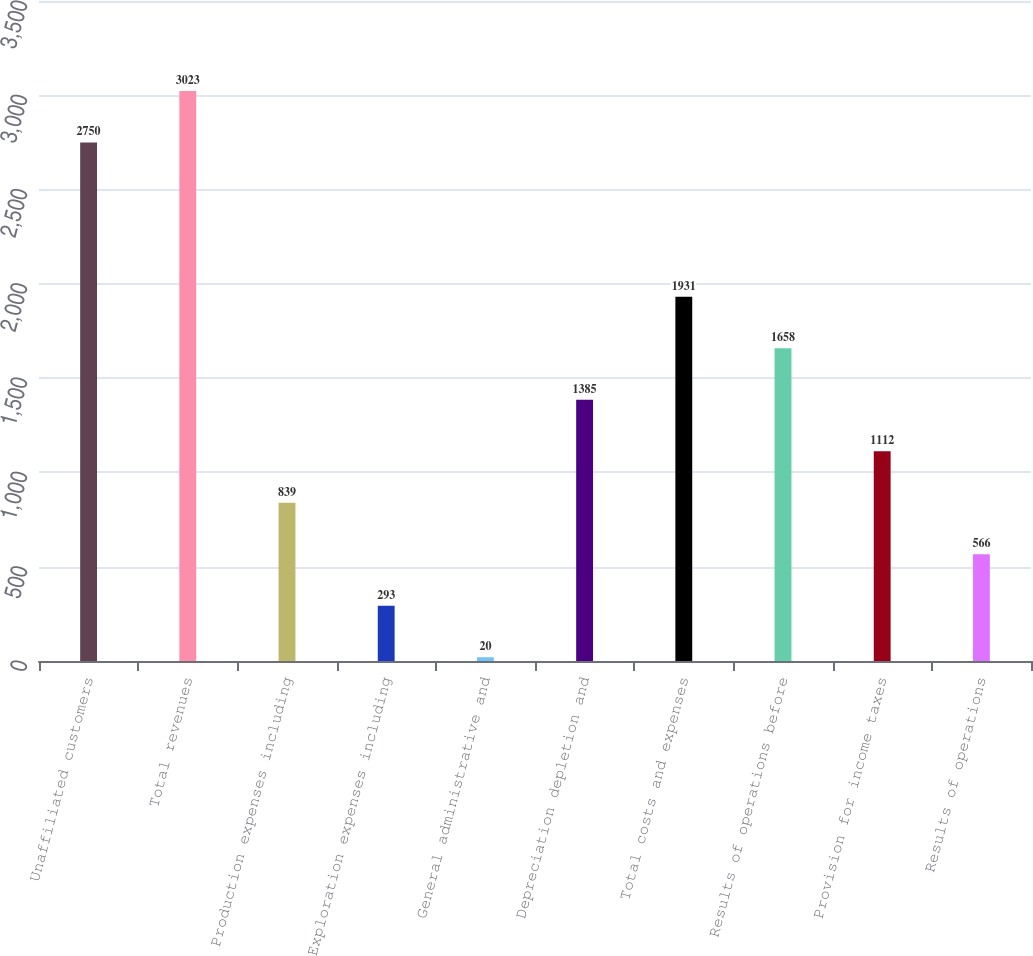Convert chart to OTSL. <chart><loc_0><loc_0><loc_500><loc_500><bar_chart><fcel>Unaffiliated customers<fcel>Total revenues<fcel>Production expenses including<fcel>Exploration expenses including<fcel>General administrative and<fcel>Depreciation depletion and<fcel>Total costs and expenses<fcel>Results of operations before<fcel>Provision for income taxes<fcel>Results of operations<nl><fcel>2750<fcel>3023<fcel>839<fcel>293<fcel>20<fcel>1385<fcel>1931<fcel>1658<fcel>1112<fcel>566<nl></chart> 